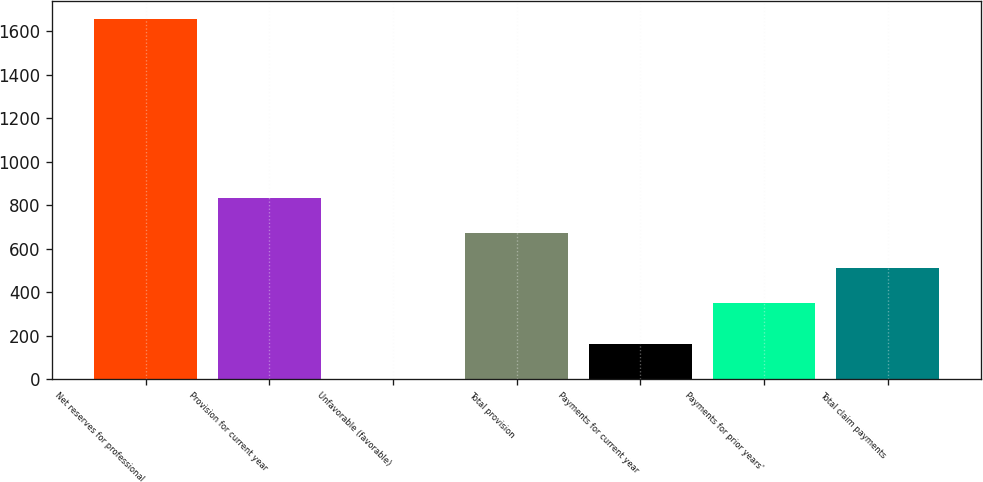<chart> <loc_0><loc_0><loc_500><loc_500><bar_chart><fcel>Net reserves for professional<fcel>Provision for current year<fcel>Unfavorable (favorable)<fcel>Total provision<fcel>Payments for current year<fcel>Payments for prior years'<fcel>Total claim payments<nl><fcel>1654.2<fcel>830.6<fcel>1<fcel>670.4<fcel>161.2<fcel>350<fcel>510.2<nl></chart> 